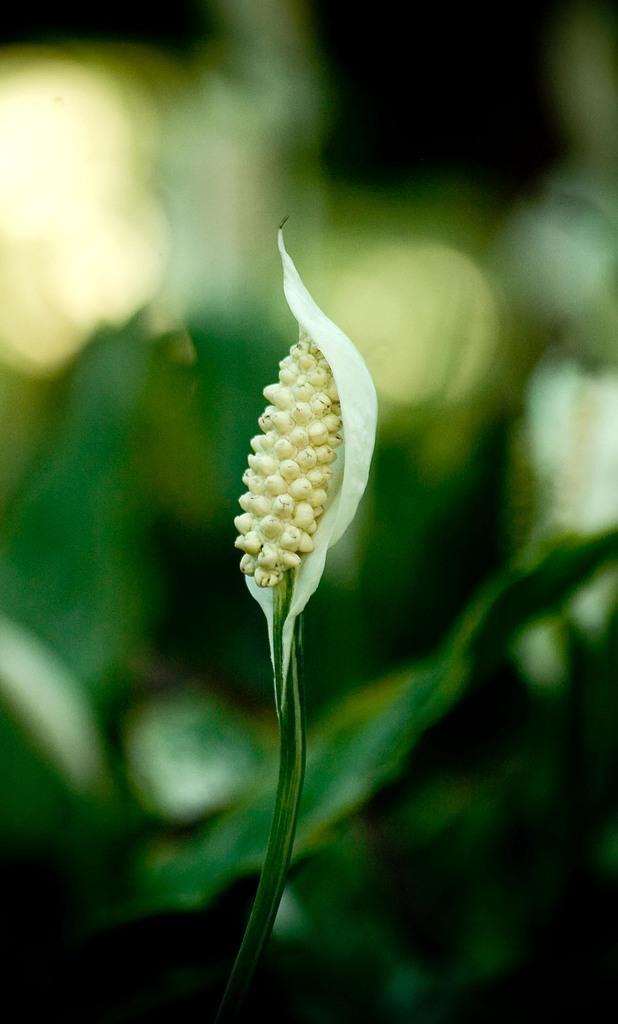Could you give a brief overview of what you see in this image? In the middle of the image we can see a flower. Background of the image is blur. 